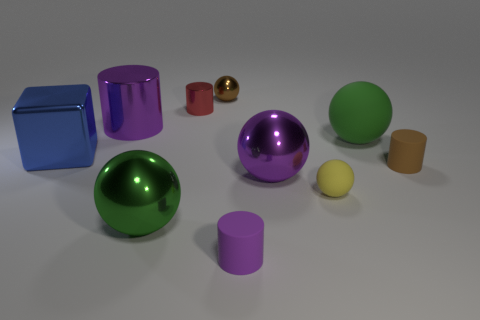There is a big metallic object that is the same color as the big cylinder; what shape is it?
Ensure brevity in your answer.  Sphere. The tiny shiny cylinder has what color?
Give a very brief answer. Red. There is a rubber cylinder that is behind the yellow object; what size is it?
Offer a terse response. Small. How many big matte objects are the same color as the small matte sphere?
Give a very brief answer. 0. There is a tiny matte sphere that is left of the small brown matte cylinder; is there a big sphere that is on the left side of it?
Your answer should be compact. Yes. There is a big metal sphere that is in front of the large purple shiny ball; is its color the same as the ball that is on the right side of the yellow object?
Offer a very short reply. Yes. What is the color of the other metallic thing that is the same size as the brown metallic thing?
Offer a very short reply. Red. Is the number of small balls that are behind the tiny red object the same as the number of big metallic cylinders that are right of the big purple shiny ball?
Offer a very short reply. No. What material is the tiny brown thing that is to the left of the green sphere that is behind the brown cylinder made of?
Make the answer very short. Metal. What number of objects are small yellow metal cylinders or tiny purple matte objects?
Provide a succinct answer. 1. 